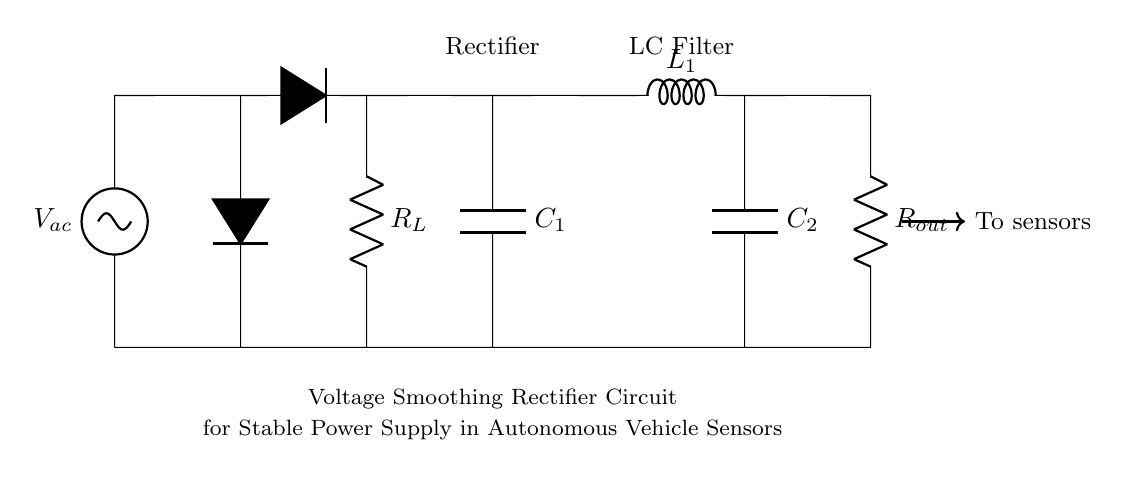What type of circuit is shown? The circuit is a voltage smoothing rectifier circuit, as indicated by the title. It is designed to convert AC voltage to a stable DC voltage suitable for powering sensors in autonomous vehicles.
Answer: Voltage smoothing rectifier circuit What is the purpose of the capacitor C1? Capacitor C1 is used for voltage smoothing; it charges when the rectifier allows current through and releases stored energy when the current drops, thus reducing voltage fluctuations.
Answer: Voltage smoothing How many diodes are present in the circuit? There are two diodes shown in the circuit, which form part of the rectifying configuration to convert AC to DC.
Answer: Two What components are used in the LC filter? The LC filter consists of an inductor L1 and capacitor C2, which work together to further smooth the output voltage by filtering out high-frequency noise from the power supply.
Answer: Inductor and capacitor What is the role of the load resistor R_L? R_L represents the load connected to the circuit; it consumes the power from the smoothed DC output and determines the current flowing in the circuit.
Answer: Load resistor What does the arrow labeled "To sensors" indicate? The arrow indicates that the output from the circuit is directed towards the sensors, implying that this circuit powers those sensors.
Answer: Power supply How does the output voltage stability compare to the input voltage? The output voltage is more stable than the input AC voltage, due to the action of the rectifier and the smoothing capabilities of the LC filter, which minimize fluctuations.
Answer: More stable 